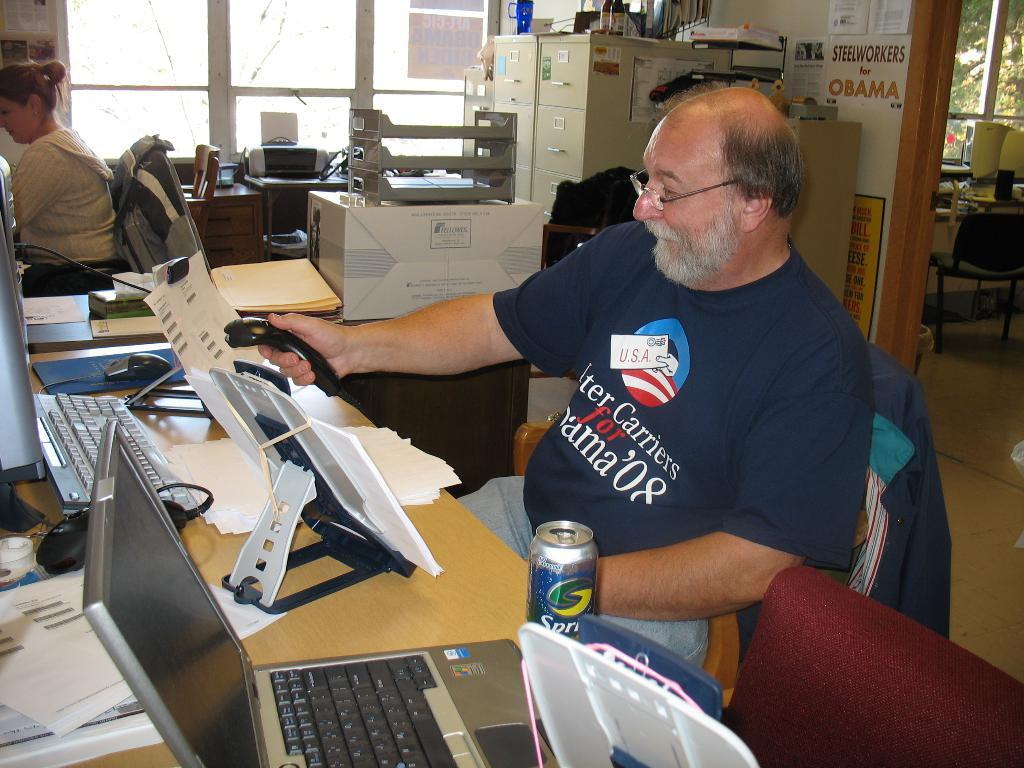How many people are present in the image? There are two people in the image, a woman and a man. What are the woman and the man doing in the image? Both the woman and the man are sitting on chairs. What objects can be seen on the table in the image? There are papers, a can, and a laptop on the table in the image. What type of government is depicted in the image? There is no depiction of a government in the image; it features a woman, a man, and objects on a table. Can you see a mountain in the background of the image? There is no mountain visible in the image; it only shows a woman, a man, and objects on a table. 